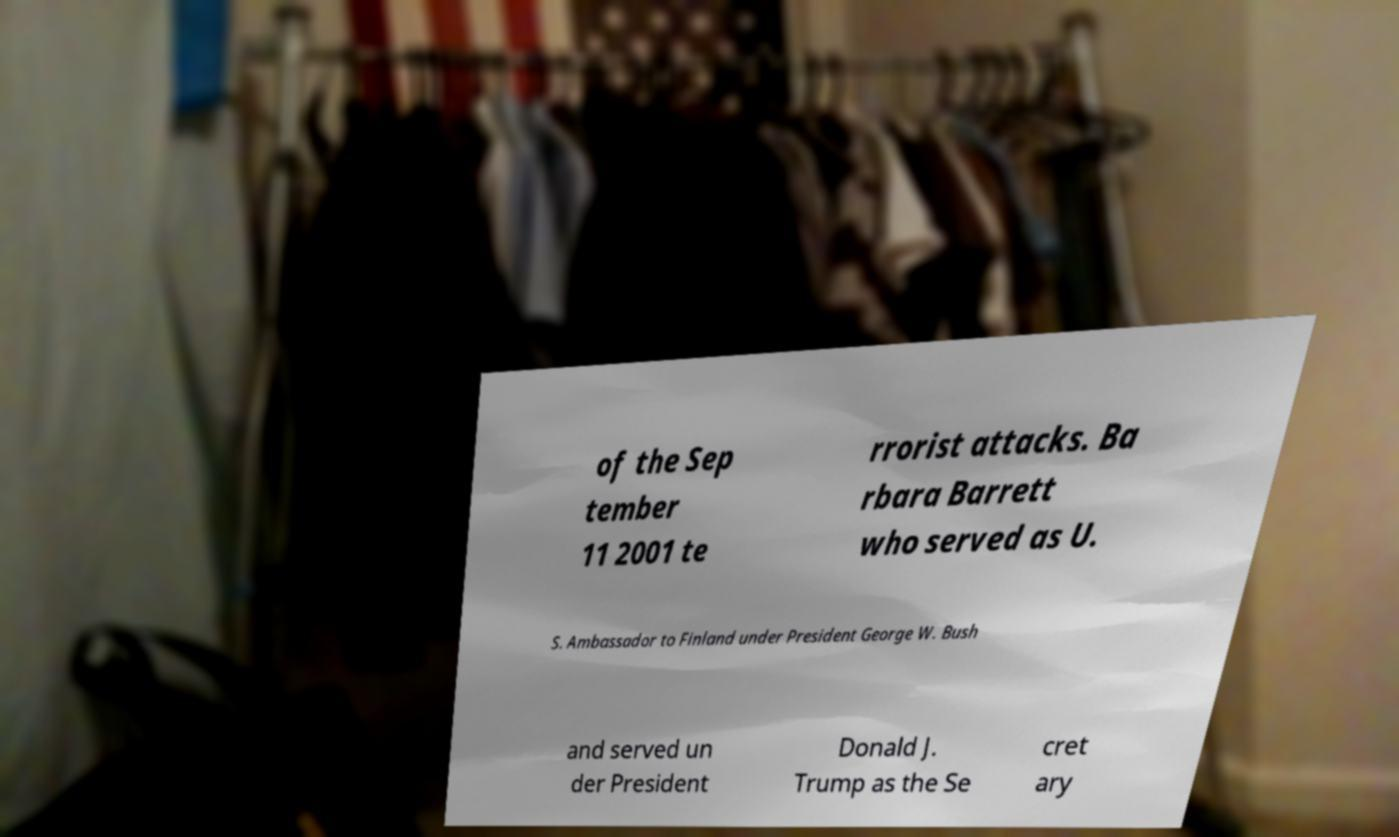Please identify and transcribe the text found in this image. of the Sep tember 11 2001 te rrorist attacks. Ba rbara Barrett who served as U. S. Ambassador to Finland under President George W. Bush and served un der President Donald J. Trump as the Se cret ary 